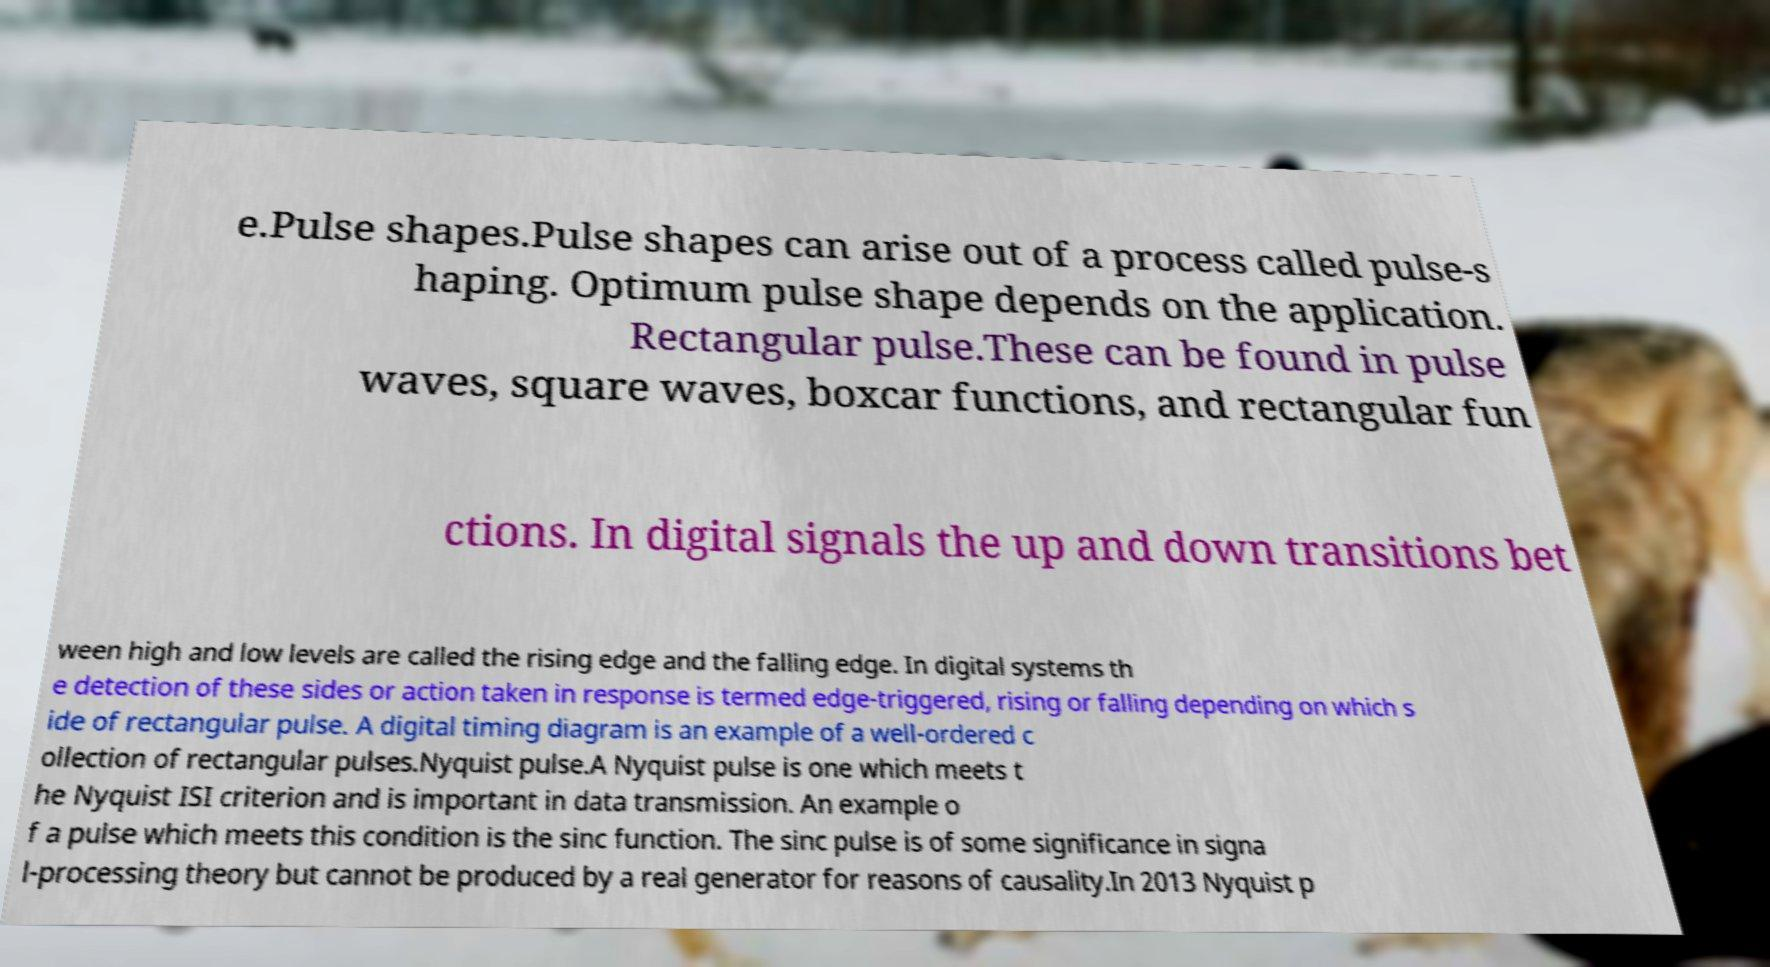There's text embedded in this image that I need extracted. Can you transcribe it verbatim? e.Pulse shapes.Pulse shapes can arise out of a process called pulse-s haping. Optimum pulse shape depends on the application. Rectangular pulse.These can be found in pulse waves, square waves, boxcar functions, and rectangular fun ctions. In digital signals the up and down transitions bet ween high and low levels are called the rising edge and the falling edge. In digital systems th e detection of these sides or action taken in response is termed edge-triggered, rising or falling depending on which s ide of rectangular pulse. A digital timing diagram is an example of a well-ordered c ollection of rectangular pulses.Nyquist pulse.A Nyquist pulse is one which meets t he Nyquist ISI criterion and is important in data transmission. An example o f a pulse which meets this condition is the sinc function. The sinc pulse is of some significance in signa l-processing theory but cannot be produced by a real generator for reasons of causality.In 2013 Nyquist p 